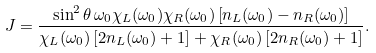Convert formula to latex. <formula><loc_0><loc_0><loc_500><loc_500>J = \frac { \sin ^ { 2 } \theta \, \omega _ { 0 } \chi _ { L } ( \omega _ { 0 } ) \chi _ { R } ( \omega _ { 0 } ) \left [ n _ { L } ( \omega _ { 0 } ) - n _ { R } ( \omega _ { 0 } ) \right ] } { \chi _ { L } ( \omega _ { 0 } ) \left [ 2 n _ { L } ( \omega _ { 0 } ) + 1 \right ] + \chi _ { R } ( \omega _ { 0 } ) \left [ 2 n _ { R } ( \omega _ { 0 } ) + 1 \right ] } .</formula> 